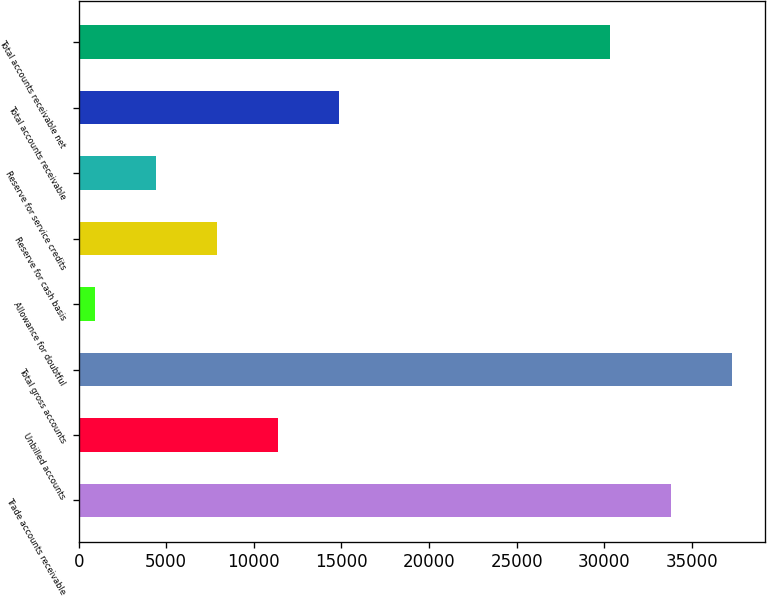Convert chart to OTSL. <chart><loc_0><loc_0><loc_500><loc_500><bar_chart><fcel>Trade accounts receivable<fcel>Unbilled accounts<fcel>Total gross accounts<fcel>Allowance for doubtful<fcel>Reserve for cash basis<fcel>Reserve for service credits<fcel>Total accounts receivable<fcel>Total accounts receivable net<nl><fcel>33815.7<fcel>11376.1<fcel>37298.4<fcel>928<fcel>7893.4<fcel>4410.7<fcel>14858.8<fcel>30333<nl></chart> 